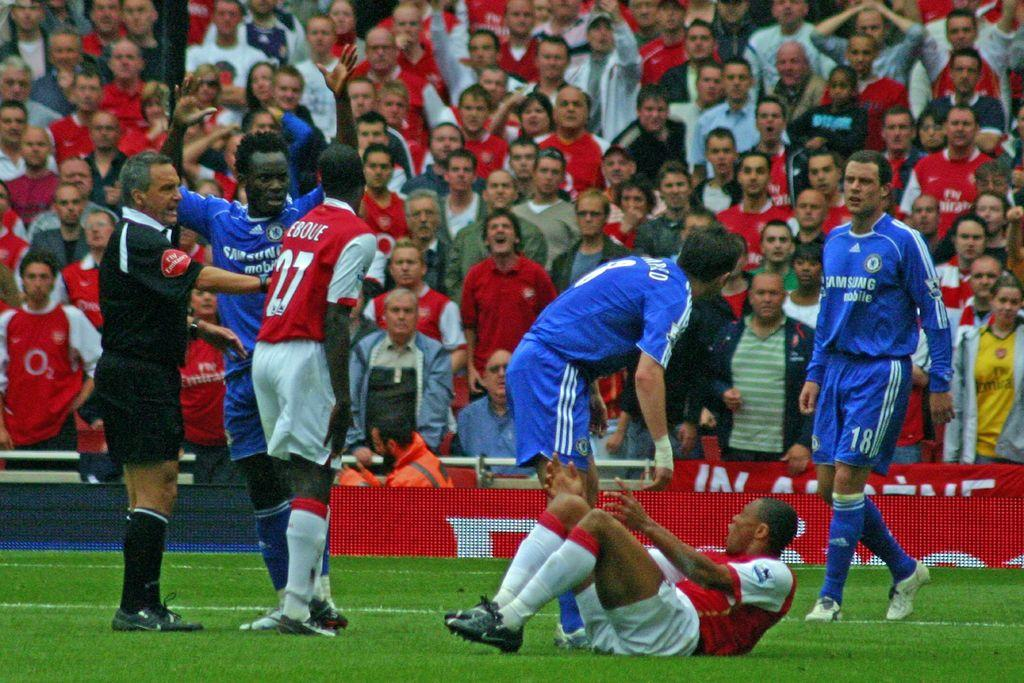<image>
Give a short and clear explanation of the subsequent image. In a soccer game, the men in the blue jerseys have Samsung written on the front. 